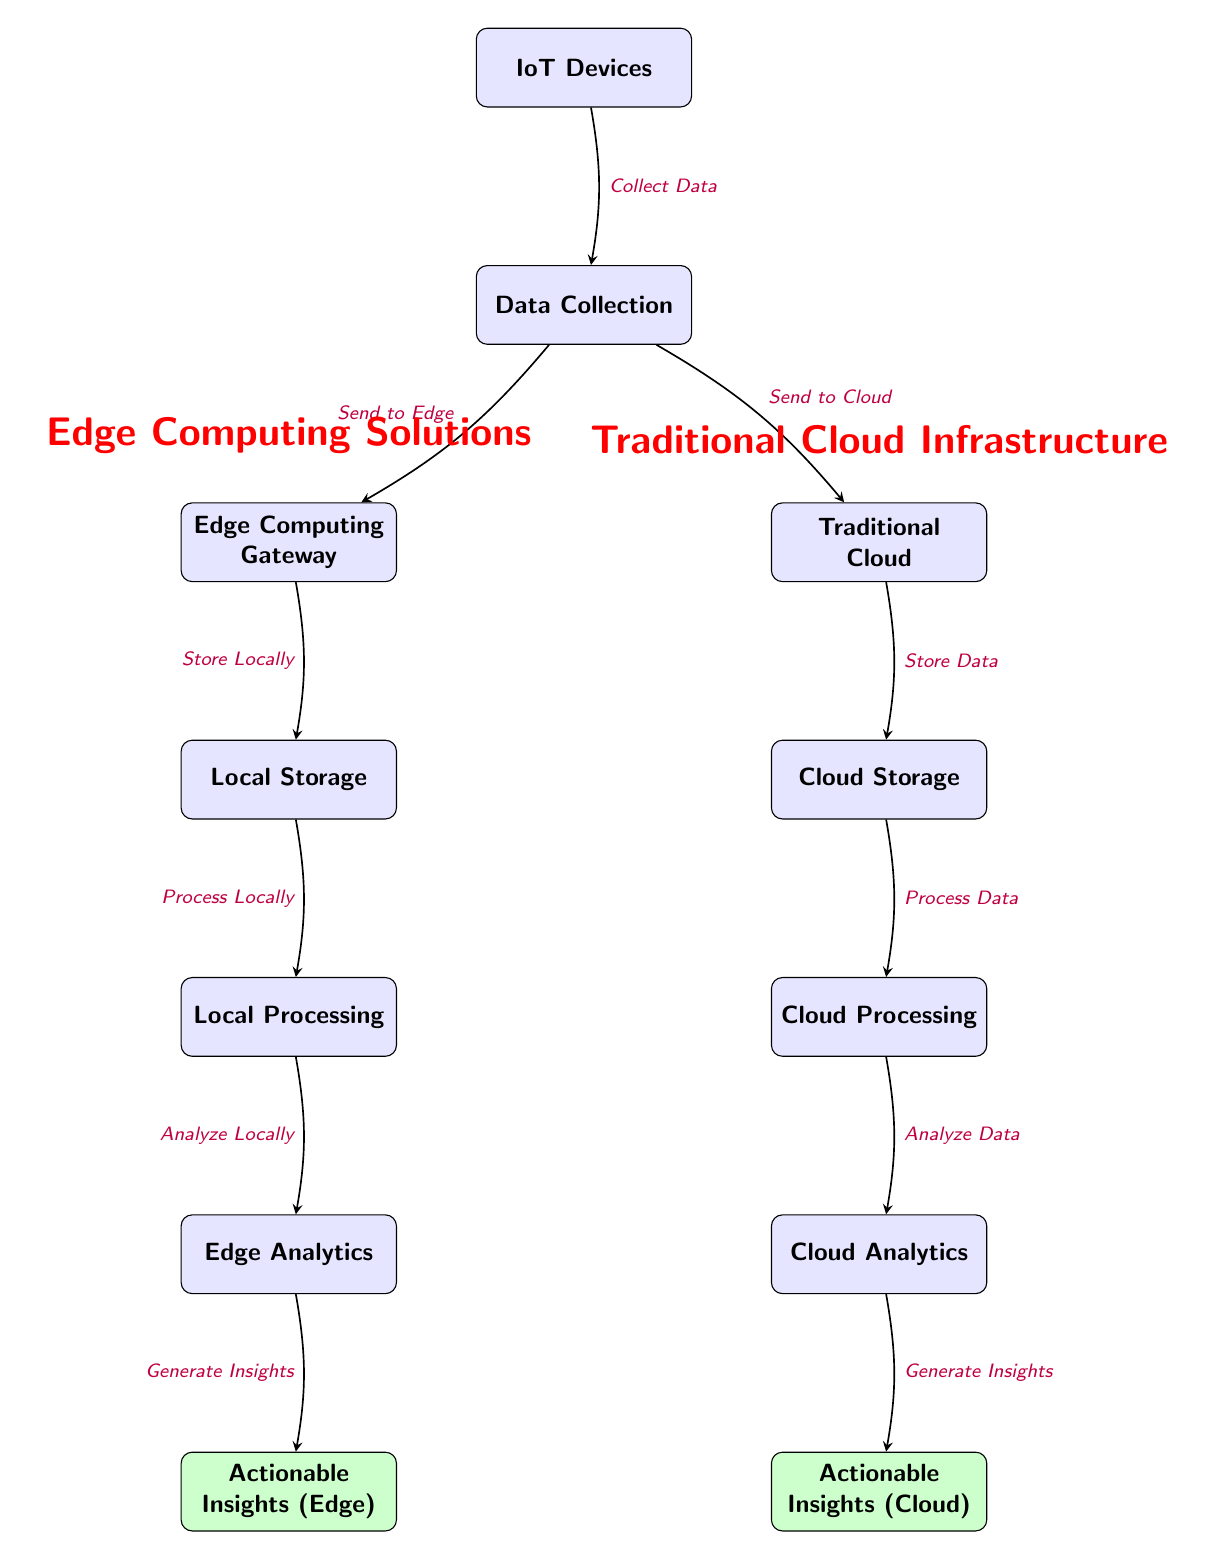What's the first step in the Traditional Cloud Infrastructure workflow? The first step is "Collect Data," which is shown as the arrow pointing from IoT Devices to Data Collection.
Answer: Collect Data How many nodes are present in the Edge Computing Solutions part of the diagram? In the Edge Computing Solutions section, there are five nodes: Edge Computing Gateway, Local Storage, Local Processing, Edge Analytics, and Actionable Insights (Edge).
Answer: Five What does the arrow between Data Collection and the Edge Computing Gateway indicate? The arrow indicates that data is sent to the Edge Computing Gateway from Data Collection, represented by the label "Send to Edge."
Answer: Send to Edge What is the final outcome for Traditional Cloud Infrastructure? The final outcome for Traditional Cloud Infrastructure is "Actionable Insights (Cloud)," which is the last node in that section, generated by Cloud Analytics.
Answer: Actionable Insights (Cloud) Which component follows Local Processing in the Edge Computing Solutions workflow? The component that follows Local Processing is Edge Analytics, as indicated by the downward arrow connecting the two.
Answer: Edge Analytics What is the relationship between Cloud Storage and Cloud Processing? The relationship is that Cloud Storage is where data is stored, and Cloud Processing follows to process that stored data, as represented by arrows indicating flow.
Answer: Process Data How many edges are there in the Traditional Cloud section of the diagram? In the Traditional Cloud section, there are six edges. Each edge represents the flow of data between nodes, starting from IoT Devices and ending with Actionable Insights (Cloud).
Answer: Six What type of insights are generated in the Edge Computing Solutions? The insights generated in the Edge Computing Solutions part are termed "Actionable Insights (Edge)," which demonstrates localized data processing and analysis.
Answer: Actionable Insights (Edge) 